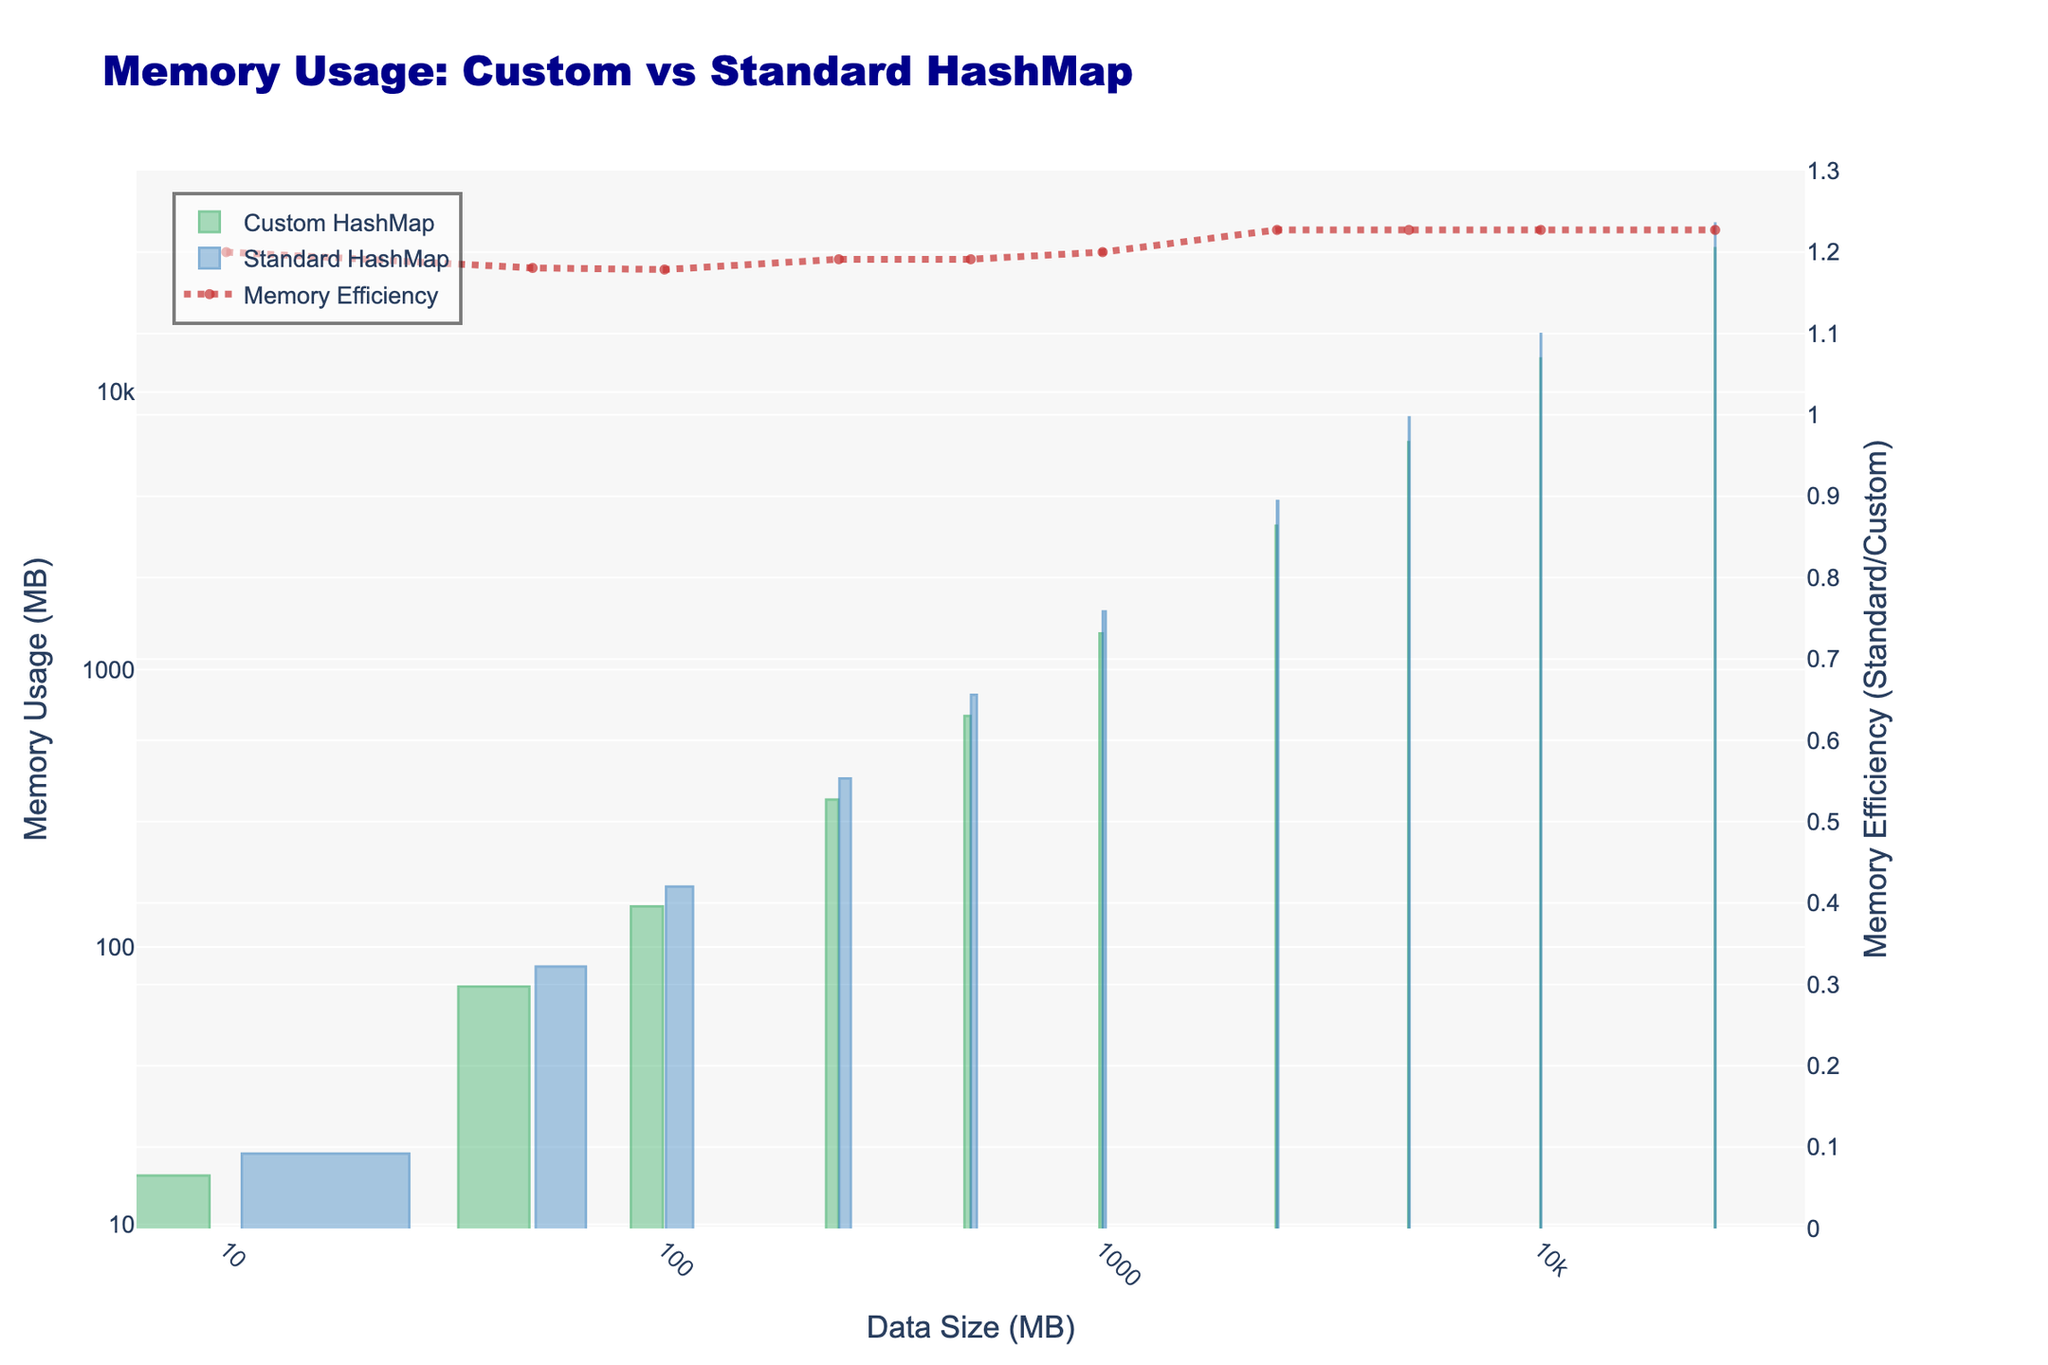What's the difference in memory usage between the Custom and Standard HashMap for a data size of 100 MB? To find the difference, subtract the Custom HashMap memory usage from the Standard HashMap memory usage for a data size of 100 MB: 165 - 140 = 25 MB.
Answer: 25 MB Which HashMap type has lower memory usage for a data size of 5000 MB? Compare the memory usage values for both HashMap types at 5000 MB: Custom HashMap uses 6600 MB, whereas the Standard HashMap uses 8100 MB. The Custom HashMap has lower memory usage.
Answer: Custom HashMap How does the memory efficiency of the Standard HashMap compare to the Custom HashMap for a data size of 10000 MB? The efficiency is calculated as the ratio of Standard to Custom HashMap memory usage. For 10000 MB, the ratio is 16200 / 13200 ≈ 1.23. The Standard HashMap uses about 1.23 times more memory than the Custom HashMap.
Answer: 1.23 What is the trend in memory usage for both HashMap types as the data size increases from 10 MB to 25000 MB? Observe that the memory usage for both Custom and Standard HashMaps increases as the data size increases. The values show an exponential increase, noticeable more in the Standard HashMap.
Answer: Exponential increase At which data size does the Standard HashMap use exactly 3 times more memory than the Custom HashMap? To find this, divide the memory usage of the Standard HashMap by the Custom HashMap for each data size, and look for the value close to 3. The ratio is 3 at a data size of 2500 MB, where 4050 / 1350 ≈ 3.
Answer: 2500 MB What color represents the Custom HashMap bars in the figure? The Custom HashMap bars are represented in green color in the figure. This is visually distinct to differentiate from the Standard HashMap bars.
Answer: Green What is the ratio of memory usage between the Standard and Custom HashMap for the smallest and largest data sizes? Calculate the ratios for 10 MB and 25000 MB. For 10 MB, the ratio is 18/15 = 1.2. For 25000 MB, the ratio is 40500/33000 ≈ 1.23.
Answer: 1.2 and 1.23 How does the memory efficiency trend as the data size increases? Observing the efficiency graph, note that the efficiency (the ratio of Standard to Custom memory usage) remains relatively stable, close to around 1.2 across different data sizes, indicating a consistent overhead with Standard HashMap.
Answer: Relatively stable around 1.2 